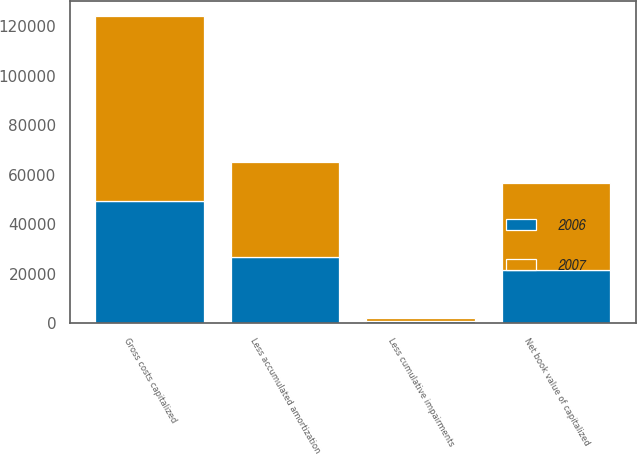Convert chart. <chart><loc_0><loc_0><loc_500><loc_500><stacked_bar_chart><ecel><fcel>Gross costs capitalized<fcel>Less cumulative impairments<fcel>Less accumulated amortization<fcel>Net book value of capitalized<nl><fcel>2007<fcel>74672<fcel>1050<fcel>38390<fcel>35232<nl><fcel>2006<fcel>49204<fcel>993<fcel>26723<fcel>21488<nl></chart> 